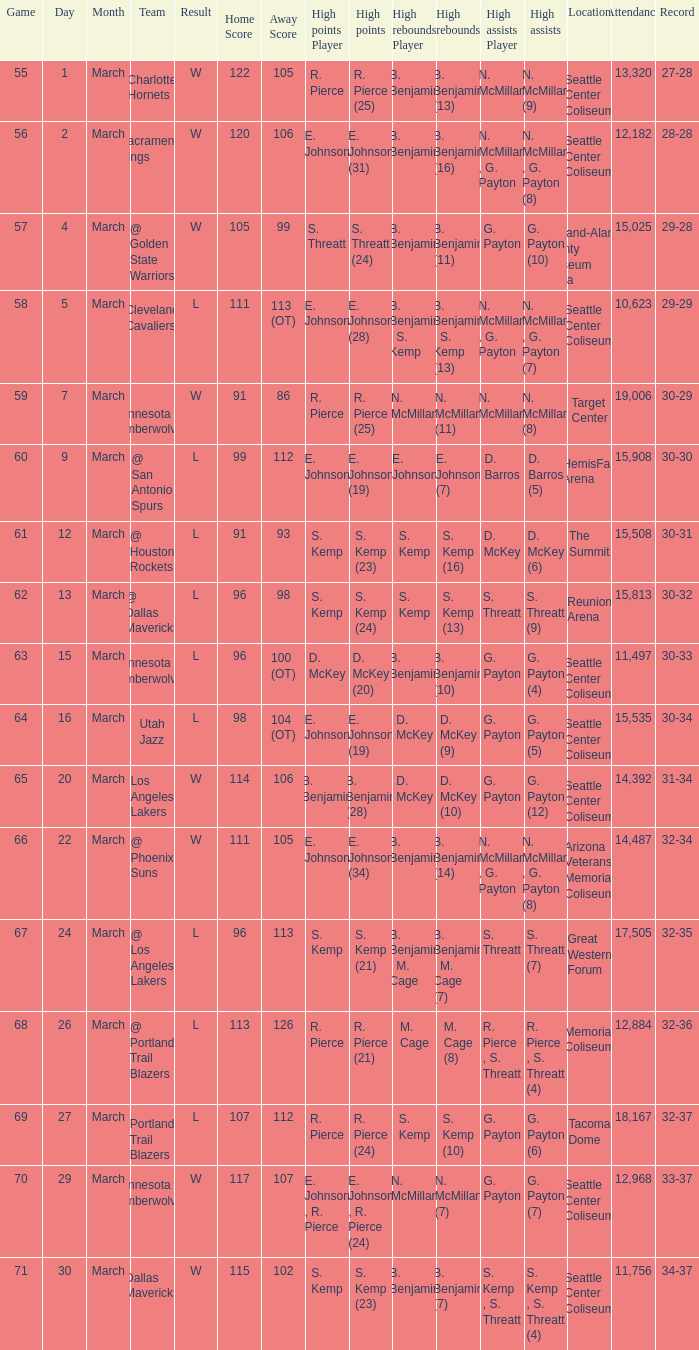Which game was played on march 2? 56.0. 